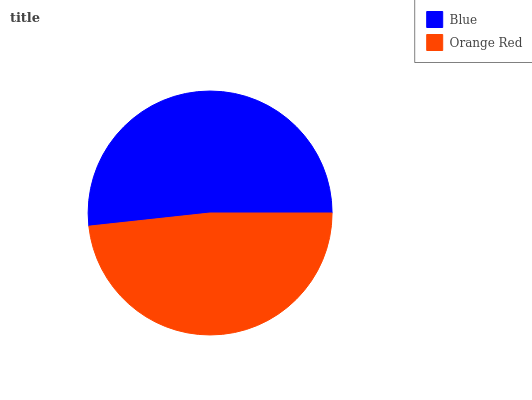Is Orange Red the minimum?
Answer yes or no. Yes. Is Blue the maximum?
Answer yes or no. Yes. Is Orange Red the maximum?
Answer yes or no. No. Is Blue greater than Orange Red?
Answer yes or no. Yes. Is Orange Red less than Blue?
Answer yes or no. Yes. Is Orange Red greater than Blue?
Answer yes or no. No. Is Blue less than Orange Red?
Answer yes or no. No. Is Blue the high median?
Answer yes or no. Yes. Is Orange Red the low median?
Answer yes or no. Yes. Is Orange Red the high median?
Answer yes or no. No. Is Blue the low median?
Answer yes or no. No. 